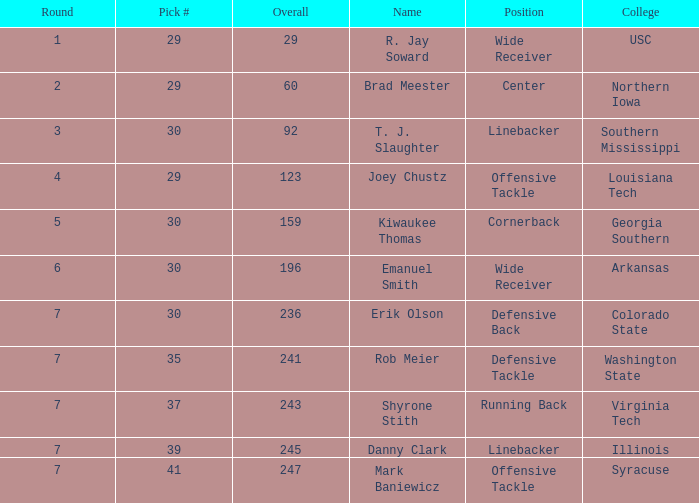In which round is the overall score 247 with a choice of fewer than 41? None. 